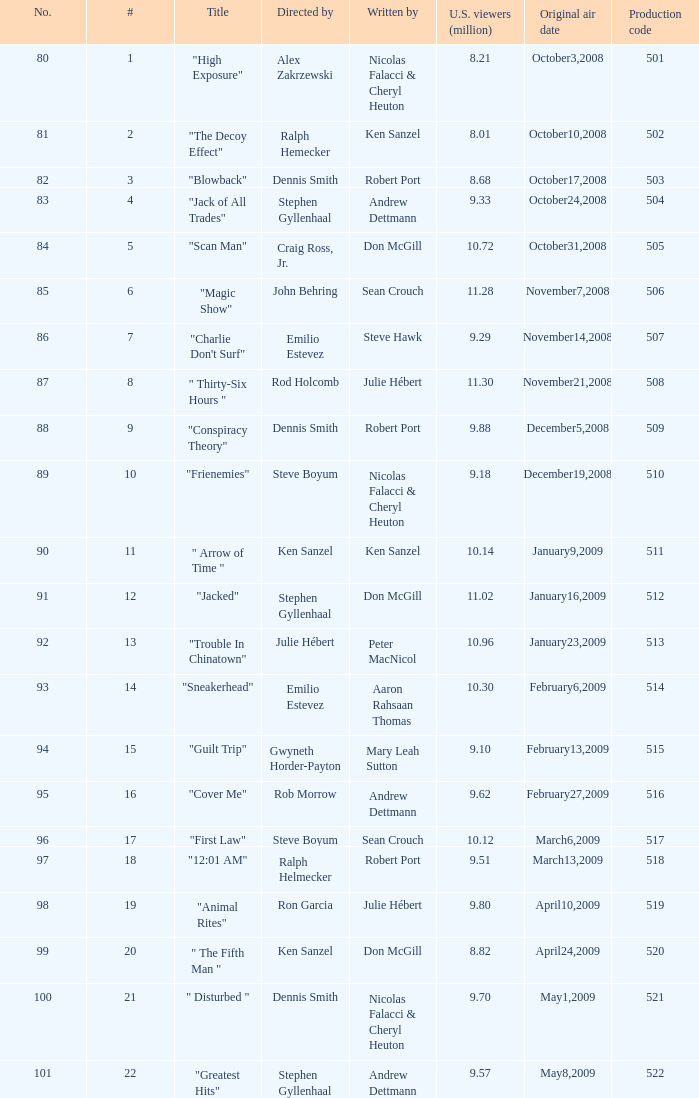What episode had 10.14 million viewers (U.S.)? 11.0. 